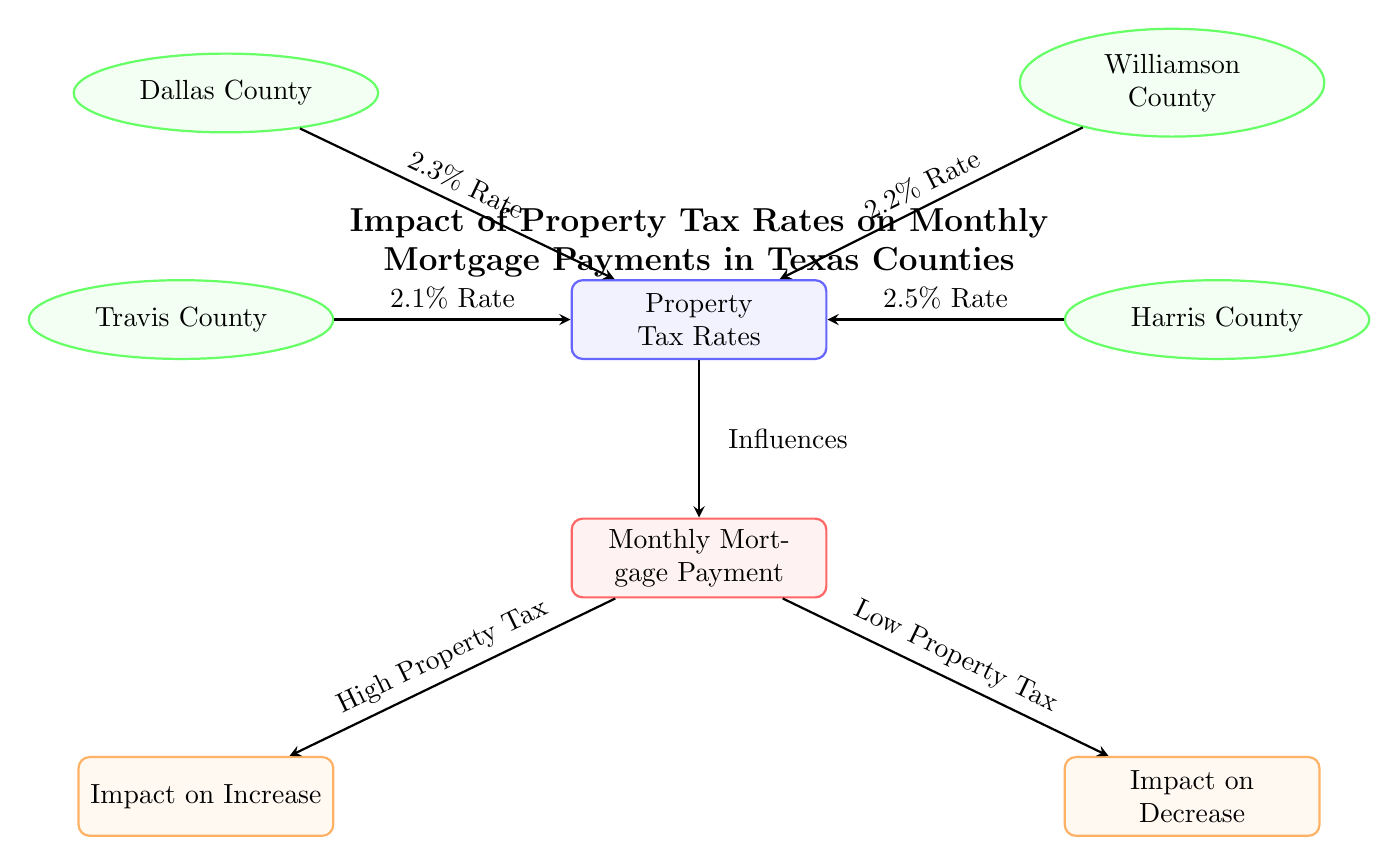What is the property tax rate in Harris County? The diagram labels Harris County with a property tax rate of 2.5%. This information is found directly from the arrow pointing from Harris County to Property Tax Rates.
Answer: 2.5% How many counties are represented in the diagram? The diagram displays four counties: Travis, Harris, Dallas, and Williamson. This can be counted by looking at the county nodes.
Answer: 4 What is the relationship between Property Tax Rates and Monthly Mortgage Payment? The diagram indicates that Property Tax Rates "Influences" Monthly Mortgage Payment, as shown by the directed arrow from Property Tax Rates to Monthly Mortgage Payment.
Answer: Influences Which county has the lowest property tax rate? By comparing the tax rates listed for each county, Travis County at 2.1% has the lowest rate. This is determined by reviewing the rates associated with each county node.
Answer: 2.1% What impact does a high property tax have on the monthly mortgage payment? The diagram indicates that a high property tax results in an "Impact on Increase," as shown by the directed arrow from Monthly Mortgage Payment to the output node.
Answer: Impact on Increase If the property tax rate increases, what happens to the mortgage payment? Following the directional flow in the diagram, an increase in property tax correlates with a higher mortgage payment, as indicated in the diagram by the connection to the "Impact on Increase" node.
Answer: Higher mortgage payment What is the property tax rate for Dallas County? The diagram explicitly identifies Dallas County with a property tax rate of 2.3%, as indicated in the label linked to the Property Tax Rates node.
Answer: 2.3% Which output node corresponds to a low property tax rate? The diagram shows that a low property tax results in an "Impact on Decrease," which is represented by the directed arrow from Monthly Mortgage Payment to the respective output node.
Answer: Impact on Decrease 